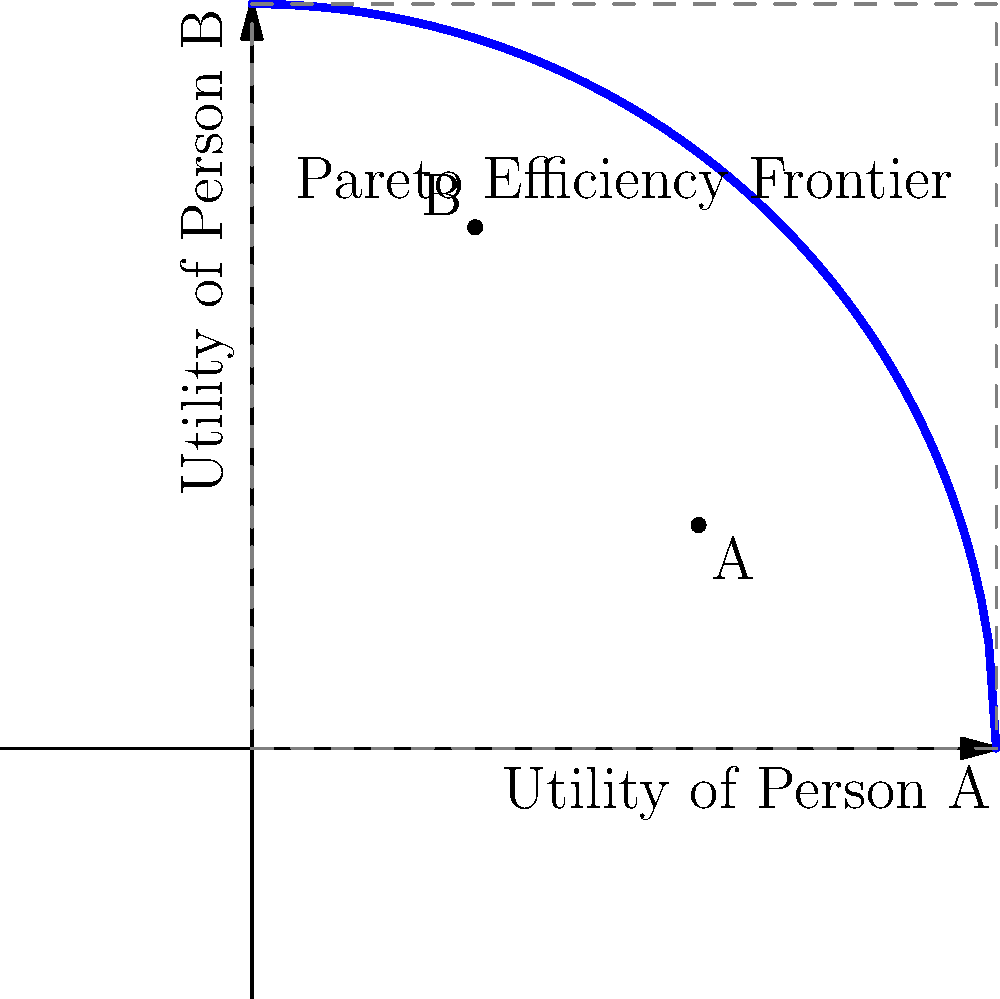In the context of behavioral economics, consider the Pareto efficiency frontier represented by the blue curve in the graph. Points A and B represent two different allocation scenarios. Which of these points is Pareto efficient, and why is the other point not on the frontier? To answer this question, we need to understand the concept of Pareto efficiency and analyze the given graph:

1. Pareto efficiency frontier: The blue curve represents all possible allocations where no individual can be made better off without making another worse off.

2. Point A (0.6, 0.3):
   - This point lies below the Pareto efficiency frontier.
   - There exist allocations above and to the right of this point that could improve utility for both individuals.

3. Point B (0.3, 0.7):
   - This point lies on the Pareto efficiency frontier.
   - Any movement along the curve from this point would increase one person's utility while decreasing the other's.

4. Comparison:
   - Point B is Pareto efficient because it's on the frontier.
   - Point A is not Pareto efficient because there are allocations that could improve utility for both individuals.

5. Behavioral economics insight:
   - This graph illustrates the trade-offs in resource allocation and the concept of efficiency in social choice theory.
   - It also highlights how behavioral factors might influence perceptions of fairness and efficiency in economic decisions.
Answer: Point B is Pareto efficient; Point A is not, as both individuals' utilities can be improved. 